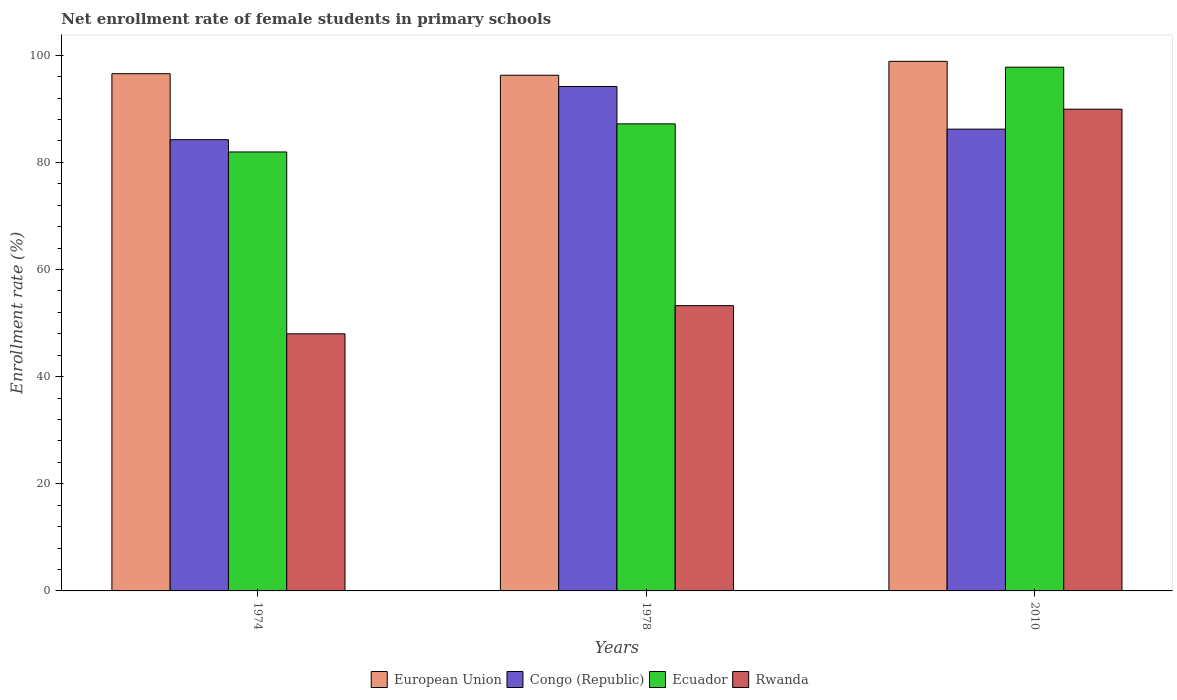Are the number of bars per tick equal to the number of legend labels?
Give a very brief answer. Yes. How many bars are there on the 1st tick from the left?
Offer a very short reply. 4. What is the label of the 1st group of bars from the left?
Offer a very short reply. 1974. What is the net enrollment rate of female students in primary schools in European Union in 1974?
Make the answer very short. 96.55. Across all years, what is the maximum net enrollment rate of female students in primary schools in Rwanda?
Provide a succinct answer. 89.93. Across all years, what is the minimum net enrollment rate of female students in primary schools in Ecuador?
Your answer should be very brief. 81.94. In which year was the net enrollment rate of female students in primary schools in Congo (Republic) minimum?
Provide a short and direct response. 1974. What is the total net enrollment rate of female students in primary schools in European Union in the graph?
Ensure brevity in your answer.  291.68. What is the difference between the net enrollment rate of female students in primary schools in European Union in 1978 and that in 2010?
Give a very brief answer. -2.59. What is the difference between the net enrollment rate of female students in primary schools in European Union in 2010 and the net enrollment rate of female students in primary schools in Ecuador in 1978?
Offer a terse response. 11.67. What is the average net enrollment rate of female students in primary schools in Congo (Republic) per year?
Provide a succinct answer. 88.2. In the year 1978, what is the difference between the net enrollment rate of female students in primary schools in Ecuador and net enrollment rate of female students in primary schools in Rwanda?
Keep it short and to the point. 33.94. In how many years, is the net enrollment rate of female students in primary schools in Ecuador greater than 56 %?
Offer a very short reply. 3. What is the ratio of the net enrollment rate of female students in primary schools in Rwanda in 1978 to that in 2010?
Offer a very short reply. 0.59. Is the difference between the net enrollment rate of female students in primary schools in Ecuador in 1974 and 1978 greater than the difference between the net enrollment rate of female students in primary schools in Rwanda in 1974 and 1978?
Provide a succinct answer. Yes. What is the difference between the highest and the second highest net enrollment rate of female students in primary schools in Rwanda?
Your answer should be very brief. 36.68. What is the difference between the highest and the lowest net enrollment rate of female students in primary schools in European Union?
Your response must be concise. 2.59. Is the sum of the net enrollment rate of female students in primary schools in European Union in 1978 and 2010 greater than the maximum net enrollment rate of female students in primary schools in Ecuador across all years?
Give a very brief answer. Yes. Is it the case that in every year, the sum of the net enrollment rate of female students in primary schools in Ecuador and net enrollment rate of female students in primary schools in Congo (Republic) is greater than the sum of net enrollment rate of female students in primary schools in Rwanda and net enrollment rate of female students in primary schools in European Union?
Keep it short and to the point. Yes. What does the 2nd bar from the left in 1974 represents?
Keep it short and to the point. Congo (Republic). What does the 2nd bar from the right in 1974 represents?
Offer a terse response. Ecuador. Does the graph contain any zero values?
Give a very brief answer. No. Where does the legend appear in the graph?
Your answer should be compact. Bottom center. How many legend labels are there?
Provide a succinct answer. 4. How are the legend labels stacked?
Give a very brief answer. Horizontal. What is the title of the graph?
Your response must be concise. Net enrollment rate of female students in primary schools. What is the label or title of the Y-axis?
Your answer should be very brief. Enrollment rate (%). What is the Enrollment rate (%) of European Union in 1974?
Offer a terse response. 96.55. What is the Enrollment rate (%) of Congo (Republic) in 1974?
Ensure brevity in your answer.  84.24. What is the Enrollment rate (%) in Ecuador in 1974?
Your answer should be very brief. 81.94. What is the Enrollment rate (%) of Rwanda in 1974?
Provide a short and direct response. 47.99. What is the Enrollment rate (%) in European Union in 1978?
Make the answer very short. 96.26. What is the Enrollment rate (%) in Congo (Republic) in 1978?
Offer a very short reply. 94.17. What is the Enrollment rate (%) in Ecuador in 1978?
Your response must be concise. 87.19. What is the Enrollment rate (%) in Rwanda in 1978?
Provide a short and direct response. 53.25. What is the Enrollment rate (%) in European Union in 2010?
Offer a very short reply. 98.86. What is the Enrollment rate (%) of Congo (Republic) in 2010?
Your answer should be very brief. 86.2. What is the Enrollment rate (%) in Ecuador in 2010?
Your answer should be very brief. 97.77. What is the Enrollment rate (%) of Rwanda in 2010?
Ensure brevity in your answer.  89.93. Across all years, what is the maximum Enrollment rate (%) in European Union?
Provide a succinct answer. 98.86. Across all years, what is the maximum Enrollment rate (%) in Congo (Republic)?
Make the answer very short. 94.17. Across all years, what is the maximum Enrollment rate (%) in Ecuador?
Your answer should be compact. 97.77. Across all years, what is the maximum Enrollment rate (%) of Rwanda?
Ensure brevity in your answer.  89.93. Across all years, what is the minimum Enrollment rate (%) of European Union?
Your answer should be compact. 96.26. Across all years, what is the minimum Enrollment rate (%) in Congo (Republic)?
Your answer should be compact. 84.24. Across all years, what is the minimum Enrollment rate (%) of Ecuador?
Your answer should be compact. 81.94. Across all years, what is the minimum Enrollment rate (%) in Rwanda?
Offer a very short reply. 47.99. What is the total Enrollment rate (%) in European Union in the graph?
Your response must be concise. 291.68. What is the total Enrollment rate (%) of Congo (Republic) in the graph?
Make the answer very short. 264.61. What is the total Enrollment rate (%) in Ecuador in the graph?
Ensure brevity in your answer.  266.9. What is the total Enrollment rate (%) in Rwanda in the graph?
Offer a terse response. 191.17. What is the difference between the Enrollment rate (%) in European Union in 1974 and that in 1978?
Keep it short and to the point. 0.29. What is the difference between the Enrollment rate (%) of Congo (Republic) in 1974 and that in 1978?
Offer a very short reply. -9.93. What is the difference between the Enrollment rate (%) of Ecuador in 1974 and that in 1978?
Keep it short and to the point. -5.25. What is the difference between the Enrollment rate (%) in Rwanda in 1974 and that in 1978?
Your response must be concise. -5.26. What is the difference between the Enrollment rate (%) in European Union in 1974 and that in 2010?
Ensure brevity in your answer.  -2.3. What is the difference between the Enrollment rate (%) of Congo (Republic) in 1974 and that in 2010?
Keep it short and to the point. -1.96. What is the difference between the Enrollment rate (%) of Ecuador in 1974 and that in 2010?
Make the answer very short. -15.82. What is the difference between the Enrollment rate (%) in Rwanda in 1974 and that in 2010?
Your answer should be compact. -41.94. What is the difference between the Enrollment rate (%) in European Union in 1978 and that in 2010?
Offer a terse response. -2.59. What is the difference between the Enrollment rate (%) of Congo (Republic) in 1978 and that in 2010?
Make the answer very short. 7.97. What is the difference between the Enrollment rate (%) in Ecuador in 1978 and that in 2010?
Your answer should be very brief. -10.58. What is the difference between the Enrollment rate (%) of Rwanda in 1978 and that in 2010?
Offer a very short reply. -36.68. What is the difference between the Enrollment rate (%) in European Union in 1974 and the Enrollment rate (%) in Congo (Republic) in 1978?
Offer a very short reply. 2.38. What is the difference between the Enrollment rate (%) in European Union in 1974 and the Enrollment rate (%) in Ecuador in 1978?
Ensure brevity in your answer.  9.36. What is the difference between the Enrollment rate (%) of European Union in 1974 and the Enrollment rate (%) of Rwanda in 1978?
Your answer should be compact. 43.3. What is the difference between the Enrollment rate (%) of Congo (Republic) in 1974 and the Enrollment rate (%) of Ecuador in 1978?
Keep it short and to the point. -2.95. What is the difference between the Enrollment rate (%) of Congo (Republic) in 1974 and the Enrollment rate (%) of Rwanda in 1978?
Keep it short and to the point. 30.99. What is the difference between the Enrollment rate (%) in Ecuador in 1974 and the Enrollment rate (%) in Rwanda in 1978?
Provide a succinct answer. 28.69. What is the difference between the Enrollment rate (%) in European Union in 1974 and the Enrollment rate (%) in Congo (Republic) in 2010?
Your response must be concise. 10.35. What is the difference between the Enrollment rate (%) in European Union in 1974 and the Enrollment rate (%) in Ecuador in 2010?
Give a very brief answer. -1.21. What is the difference between the Enrollment rate (%) of European Union in 1974 and the Enrollment rate (%) of Rwanda in 2010?
Provide a succinct answer. 6.62. What is the difference between the Enrollment rate (%) in Congo (Republic) in 1974 and the Enrollment rate (%) in Ecuador in 2010?
Make the answer very short. -13.53. What is the difference between the Enrollment rate (%) in Congo (Republic) in 1974 and the Enrollment rate (%) in Rwanda in 2010?
Your response must be concise. -5.69. What is the difference between the Enrollment rate (%) of Ecuador in 1974 and the Enrollment rate (%) of Rwanda in 2010?
Your answer should be very brief. -7.99. What is the difference between the Enrollment rate (%) in European Union in 1978 and the Enrollment rate (%) in Congo (Republic) in 2010?
Ensure brevity in your answer.  10.06. What is the difference between the Enrollment rate (%) of European Union in 1978 and the Enrollment rate (%) of Ecuador in 2010?
Make the answer very short. -1.5. What is the difference between the Enrollment rate (%) of European Union in 1978 and the Enrollment rate (%) of Rwanda in 2010?
Your response must be concise. 6.34. What is the difference between the Enrollment rate (%) in Congo (Republic) in 1978 and the Enrollment rate (%) in Ecuador in 2010?
Offer a very short reply. -3.6. What is the difference between the Enrollment rate (%) in Congo (Republic) in 1978 and the Enrollment rate (%) in Rwanda in 2010?
Keep it short and to the point. 4.24. What is the difference between the Enrollment rate (%) in Ecuador in 1978 and the Enrollment rate (%) in Rwanda in 2010?
Keep it short and to the point. -2.74. What is the average Enrollment rate (%) of European Union per year?
Ensure brevity in your answer.  97.23. What is the average Enrollment rate (%) in Congo (Republic) per year?
Offer a very short reply. 88.2. What is the average Enrollment rate (%) of Ecuador per year?
Your response must be concise. 88.97. What is the average Enrollment rate (%) of Rwanda per year?
Keep it short and to the point. 63.72. In the year 1974, what is the difference between the Enrollment rate (%) of European Union and Enrollment rate (%) of Congo (Republic)?
Offer a very short reply. 12.32. In the year 1974, what is the difference between the Enrollment rate (%) in European Union and Enrollment rate (%) in Ecuador?
Provide a short and direct response. 14.61. In the year 1974, what is the difference between the Enrollment rate (%) in European Union and Enrollment rate (%) in Rwanda?
Ensure brevity in your answer.  48.56. In the year 1974, what is the difference between the Enrollment rate (%) of Congo (Republic) and Enrollment rate (%) of Ecuador?
Provide a succinct answer. 2.29. In the year 1974, what is the difference between the Enrollment rate (%) in Congo (Republic) and Enrollment rate (%) in Rwanda?
Make the answer very short. 36.24. In the year 1974, what is the difference between the Enrollment rate (%) in Ecuador and Enrollment rate (%) in Rwanda?
Offer a terse response. 33.95. In the year 1978, what is the difference between the Enrollment rate (%) in European Union and Enrollment rate (%) in Congo (Republic)?
Provide a succinct answer. 2.1. In the year 1978, what is the difference between the Enrollment rate (%) in European Union and Enrollment rate (%) in Ecuador?
Your response must be concise. 9.07. In the year 1978, what is the difference between the Enrollment rate (%) in European Union and Enrollment rate (%) in Rwanda?
Offer a terse response. 43.02. In the year 1978, what is the difference between the Enrollment rate (%) in Congo (Republic) and Enrollment rate (%) in Ecuador?
Offer a terse response. 6.98. In the year 1978, what is the difference between the Enrollment rate (%) of Congo (Republic) and Enrollment rate (%) of Rwanda?
Ensure brevity in your answer.  40.92. In the year 1978, what is the difference between the Enrollment rate (%) of Ecuador and Enrollment rate (%) of Rwanda?
Your answer should be very brief. 33.94. In the year 2010, what is the difference between the Enrollment rate (%) in European Union and Enrollment rate (%) in Congo (Republic)?
Offer a very short reply. 12.65. In the year 2010, what is the difference between the Enrollment rate (%) in European Union and Enrollment rate (%) in Ecuador?
Provide a succinct answer. 1.09. In the year 2010, what is the difference between the Enrollment rate (%) in European Union and Enrollment rate (%) in Rwanda?
Keep it short and to the point. 8.93. In the year 2010, what is the difference between the Enrollment rate (%) in Congo (Republic) and Enrollment rate (%) in Ecuador?
Provide a short and direct response. -11.57. In the year 2010, what is the difference between the Enrollment rate (%) of Congo (Republic) and Enrollment rate (%) of Rwanda?
Offer a very short reply. -3.73. In the year 2010, what is the difference between the Enrollment rate (%) in Ecuador and Enrollment rate (%) in Rwanda?
Your answer should be compact. 7.84. What is the ratio of the Enrollment rate (%) of Congo (Republic) in 1974 to that in 1978?
Give a very brief answer. 0.89. What is the ratio of the Enrollment rate (%) of Ecuador in 1974 to that in 1978?
Offer a terse response. 0.94. What is the ratio of the Enrollment rate (%) of Rwanda in 1974 to that in 1978?
Ensure brevity in your answer.  0.9. What is the ratio of the Enrollment rate (%) of European Union in 1974 to that in 2010?
Give a very brief answer. 0.98. What is the ratio of the Enrollment rate (%) of Congo (Republic) in 1974 to that in 2010?
Offer a terse response. 0.98. What is the ratio of the Enrollment rate (%) in Ecuador in 1974 to that in 2010?
Provide a short and direct response. 0.84. What is the ratio of the Enrollment rate (%) in Rwanda in 1974 to that in 2010?
Your answer should be very brief. 0.53. What is the ratio of the Enrollment rate (%) of European Union in 1978 to that in 2010?
Keep it short and to the point. 0.97. What is the ratio of the Enrollment rate (%) in Congo (Republic) in 1978 to that in 2010?
Keep it short and to the point. 1.09. What is the ratio of the Enrollment rate (%) of Ecuador in 1978 to that in 2010?
Your response must be concise. 0.89. What is the ratio of the Enrollment rate (%) of Rwanda in 1978 to that in 2010?
Your answer should be very brief. 0.59. What is the difference between the highest and the second highest Enrollment rate (%) in European Union?
Make the answer very short. 2.3. What is the difference between the highest and the second highest Enrollment rate (%) in Congo (Republic)?
Offer a very short reply. 7.97. What is the difference between the highest and the second highest Enrollment rate (%) of Ecuador?
Your answer should be very brief. 10.58. What is the difference between the highest and the second highest Enrollment rate (%) of Rwanda?
Provide a short and direct response. 36.68. What is the difference between the highest and the lowest Enrollment rate (%) of European Union?
Keep it short and to the point. 2.59. What is the difference between the highest and the lowest Enrollment rate (%) of Congo (Republic)?
Make the answer very short. 9.93. What is the difference between the highest and the lowest Enrollment rate (%) in Ecuador?
Offer a very short reply. 15.82. What is the difference between the highest and the lowest Enrollment rate (%) in Rwanda?
Offer a very short reply. 41.94. 